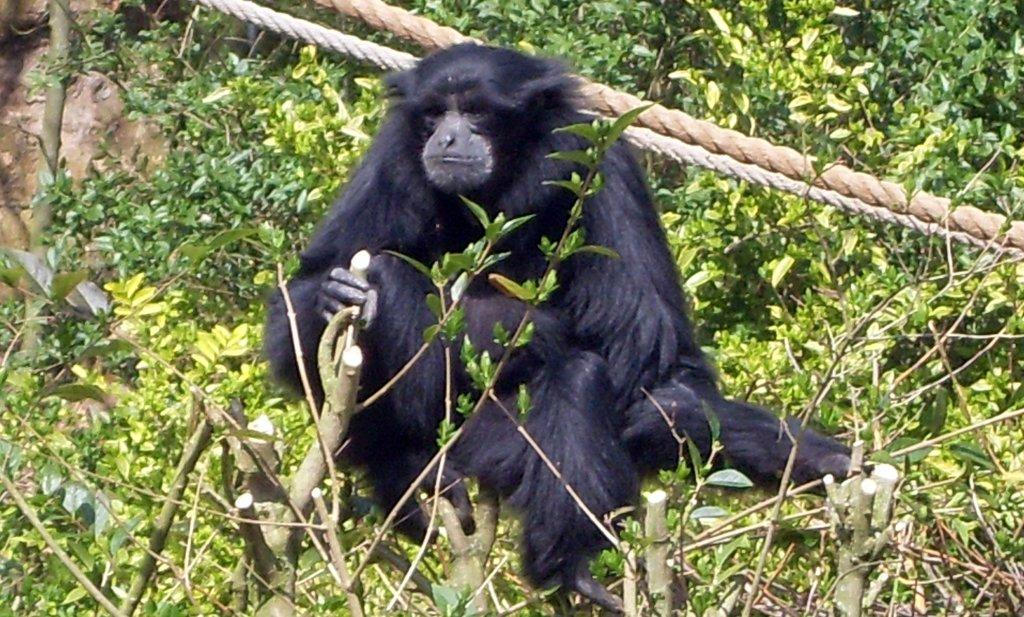What type of animal is in the image? There is a chimpanzee in the image. What else can be seen in the image besides the chimpanzee? There are plants and ropes in the image. What type of reward does the bear receive after completing the mitten challenge in the image? There is no bear or mitten challenge present in the image; it features a chimpanzee, plants, and ropes. 